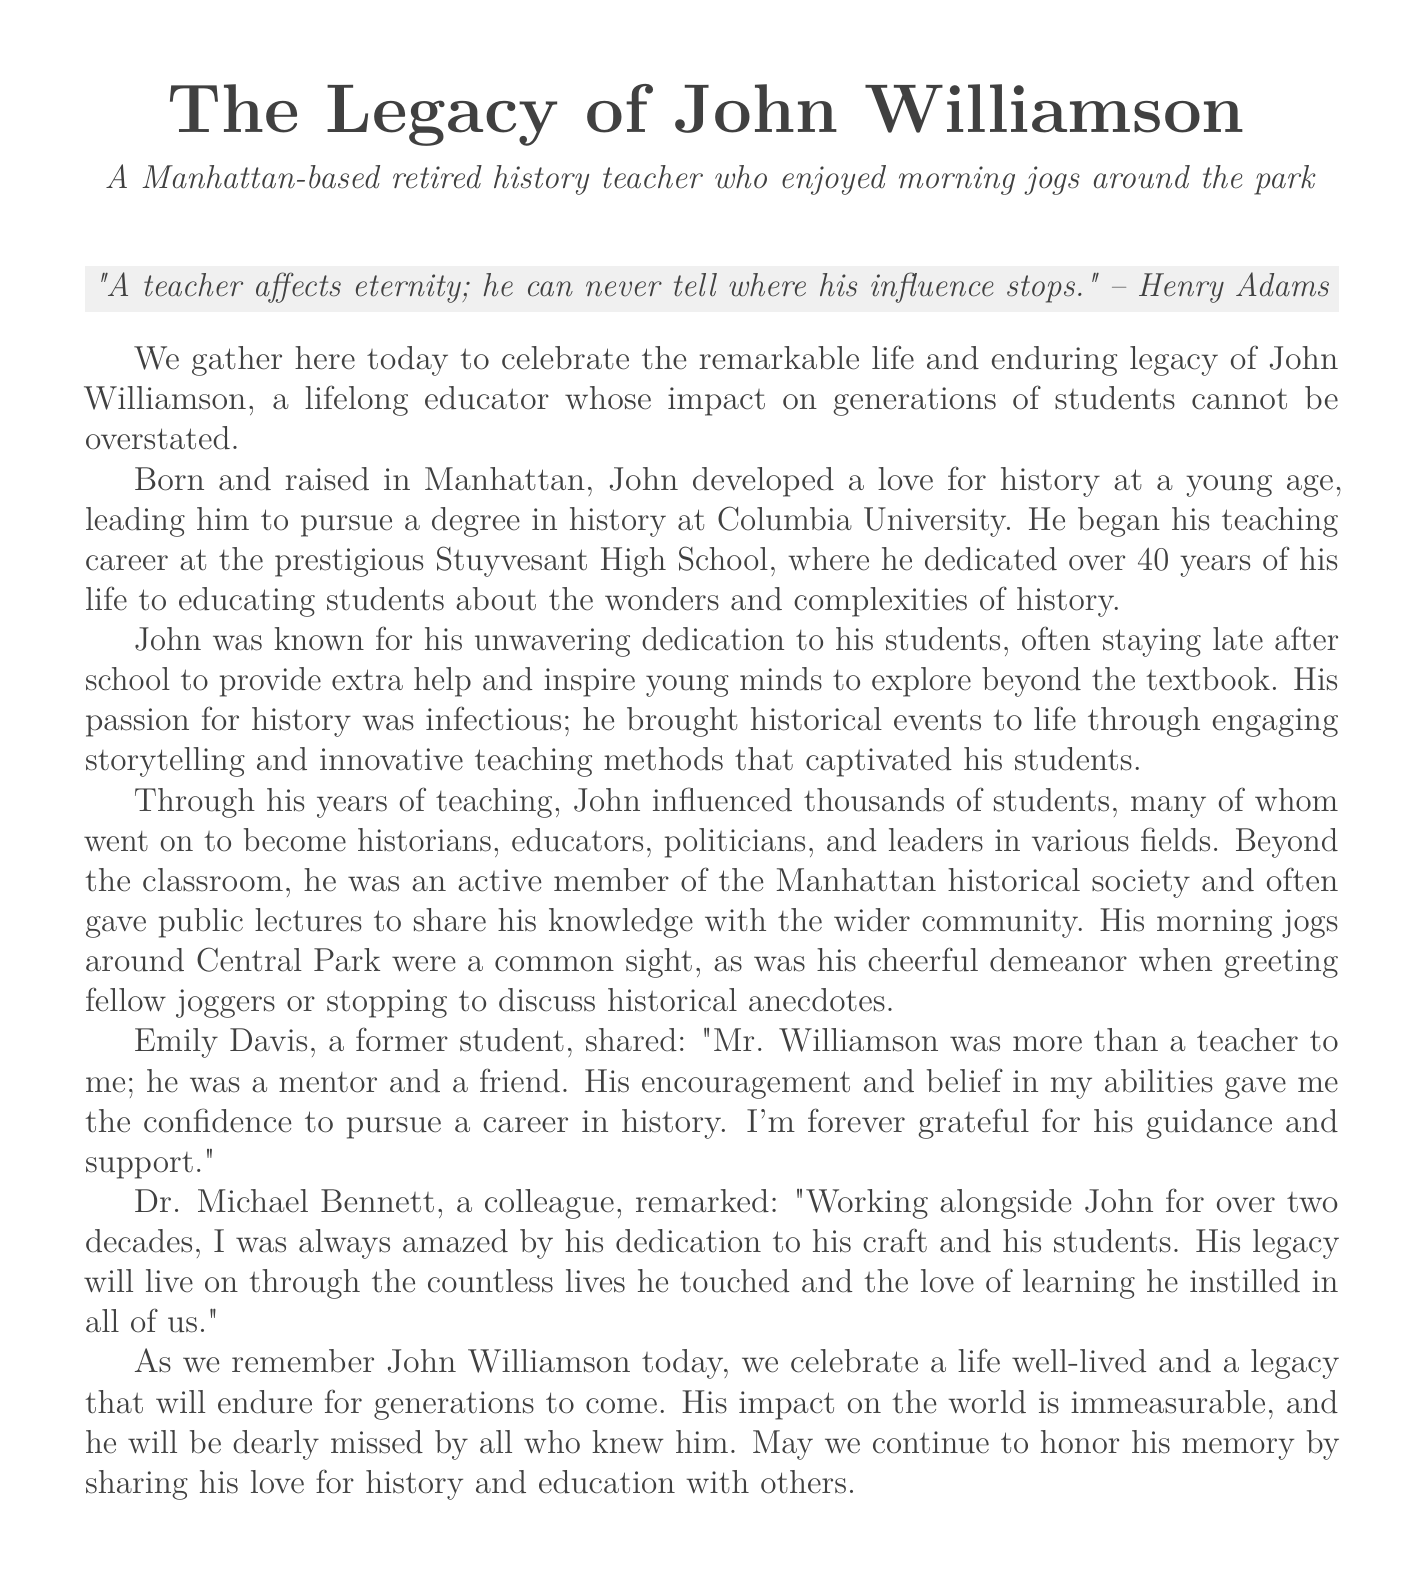What was the name of the educator being celebrated? The document highlights the life and legacy of John Williamson as a lifelong educator.
Answer: John Williamson What school did John Williamson teach at? John dedicated over 40 years of his life to educating students at Stuyvesant High School.
Answer: Stuyvesant High School How long did John Williamson teach? He devoted over 40 years to his teaching career.
Answer: over 40 years What degree did John Williamson pursue? The document states that he pursued a degree in history at Columbia University.
Answer: history Who expressed gratitude for John Williamson's guidance? Emily Davis, a former student, shared her appreciation and gratitude.
Answer: Emily Davis What did Dr. Michael Bennett say about John Williamson? He remarked on John's dedication to his craft and students, noting that his legacy will endure through the lives he touched.
Answer: His legacy will live on through the countless lives he touched What was a common sight in Central Park related to John Williamson? John was often seen jogging around Central Park, which was a familiar scene to many.
Answer: jogging around Central Park What was John Williamson's approach to teaching? He brought historical events to life through engaging storytelling and innovative teaching methods.
Answer: engaging storytelling and innovative teaching methods What inspirational quote is included in the document? The document features a quote by Henry Adams that reflects on the lasting influence of a teacher.
Answer: "A teacher affects eternity; he can never tell where his influence stops." 